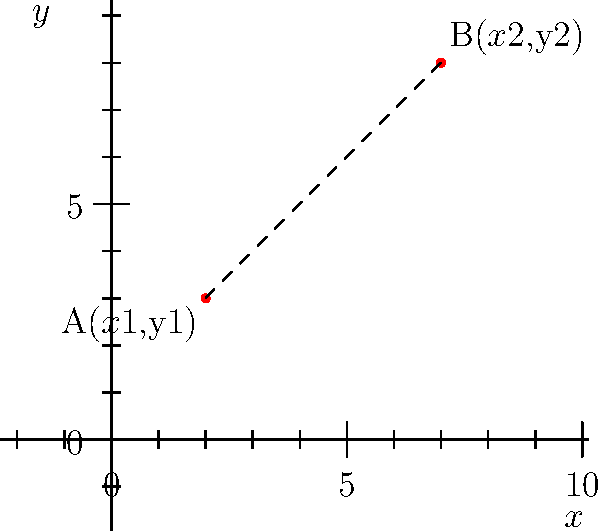As you encourage your younger sibling to explore interests beyond Batman Lego, you decide to introduce them to coordinate geometry. On a coordinate plane, point A is located at (2, 3) and point B is at (7, 8). Calculate the distance between these two points using the distance formula. Let's approach this step-by-step:

1) The distance formula between two points $(x_1, y_1)$ and $(x_2, y_2)$ is:

   $$d = \sqrt{(x_2 - x_1)^2 + (y_2 - y_1)^2}$$

2) In this case:
   - Point A: $(x_1, y_1) = (2, 3)$
   - Point B: $(x_2, y_2) = (7, 8)$

3) Let's substitute these values into the formula:

   $$d = \sqrt{(7 - 2)^2 + (8 - 3)^2}$$

4) Simplify inside the parentheses:

   $$d = \sqrt{5^2 + 5^2}$$

5) Calculate the squares:

   $$d = \sqrt{25 + 25}$$

6) Add inside the square root:

   $$d = \sqrt{50}$$

7) Simplify the square root:

   $$d = 5\sqrt{2}$$

Thus, the distance between points A and B is $5\sqrt{2}$ units.
Answer: $5\sqrt{2}$ units 